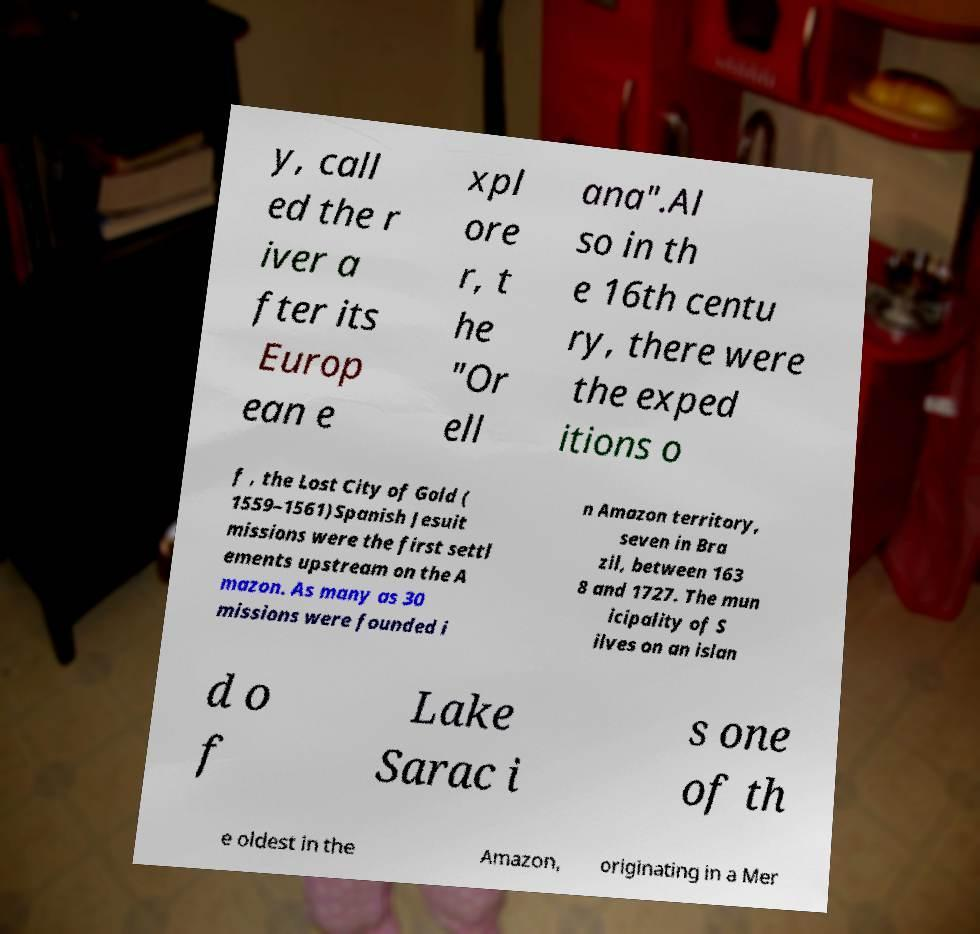Can you read and provide the text displayed in the image?This photo seems to have some interesting text. Can you extract and type it out for me? y, call ed the r iver a fter its Europ ean e xpl ore r, t he "Or ell ana".Al so in th e 16th centu ry, there were the exped itions o f , the Lost City of Gold ( 1559–1561)Spanish Jesuit missions were the first settl ements upstream on the A mazon. As many as 30 missions were founded i n Amazon territory, seven in Bra zil, between 163 8 and 1727. The mun icipality of S ilves on an islan d o f Lake Sarac i s one of th e oldest in the Amazon, originating in a Mer 